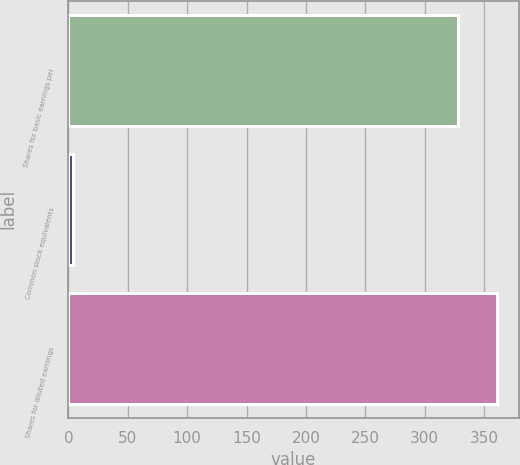Convert chart. <chart><loc_0><loc_0><loc_500><loc_500><bar_chart><fcel>Shares for basic earnings per<fcel>Common stock equivalents<fcel>Shares for diluted earnings<nl><fcel>328.5<fcel>4.1<fcel>361.35<nl></chart> 